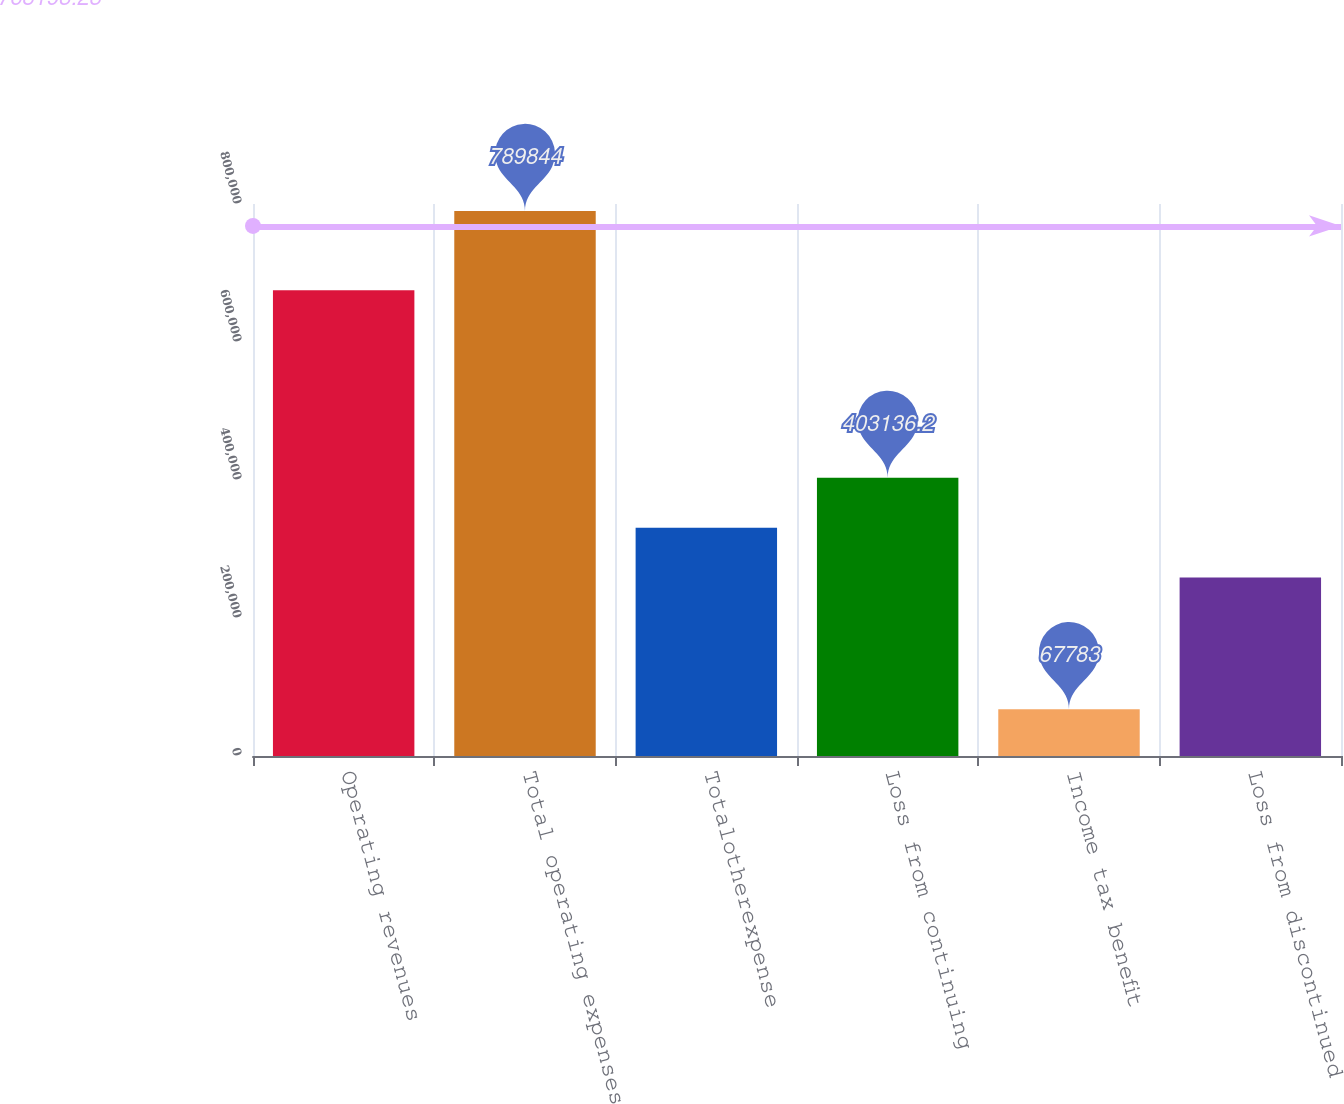<chart> <loc_0><loc_0><loc_500><loc_500><bar_chart><fcel>Operating revenues<fcel>Total operating expenses<fcel>Totalotherexpense<fcel>Loss from continuing<fcel>Income tax benefit<fcel>Loss from discontinued<nl><fcel>675082<fcel>789844<fcel>330930<fcel>403136<fcel>67783<fcel>258724<nl></chart> 